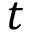<formula> <loc_0><loc_0><loc_500><loc_500>t</formula> 